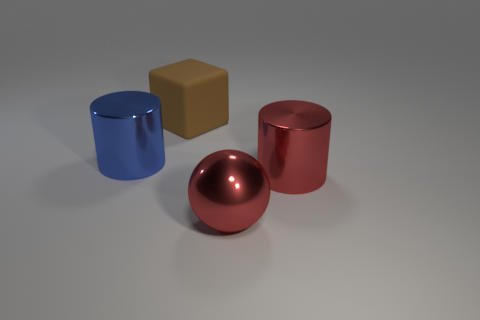There is a red cylinder; are there any metal objects behind it?
Make the answer very short. Yes. Are the cylinder behind the red cylinder and the big cube made of the same material?
Your response must be concise. No. Are there any metal cylinders that have the same color as the big metallic sphere?
Provide a short and direct response. Yes. There is a big blue metal object; what shape is it?
Offer a very short reply. Cylinder. There is a large metallic cylinder in front of the large shiny thing that is left of the large rubber thing; what color is it?
Keep it short and to the point. Red. There is a metal sphere in front of the matte block; what is its size?
Provide a succinct answer. Large. Is there a red cylinder made of the same material as the large brown thing?
Give a very brief answer. No. How many red metal objects have the same shape as the blue thing?
Offer a terse response. 1. What shape is the metal object behind the large cylinder that is on the right side of the large shiny thing to the left of the big red ball?
Offer a terse response. Cylinder. What material is the big object that is in front of the big brown matte thing and on the left side of the large sphere?
Keep it short and to the point. Metal. 